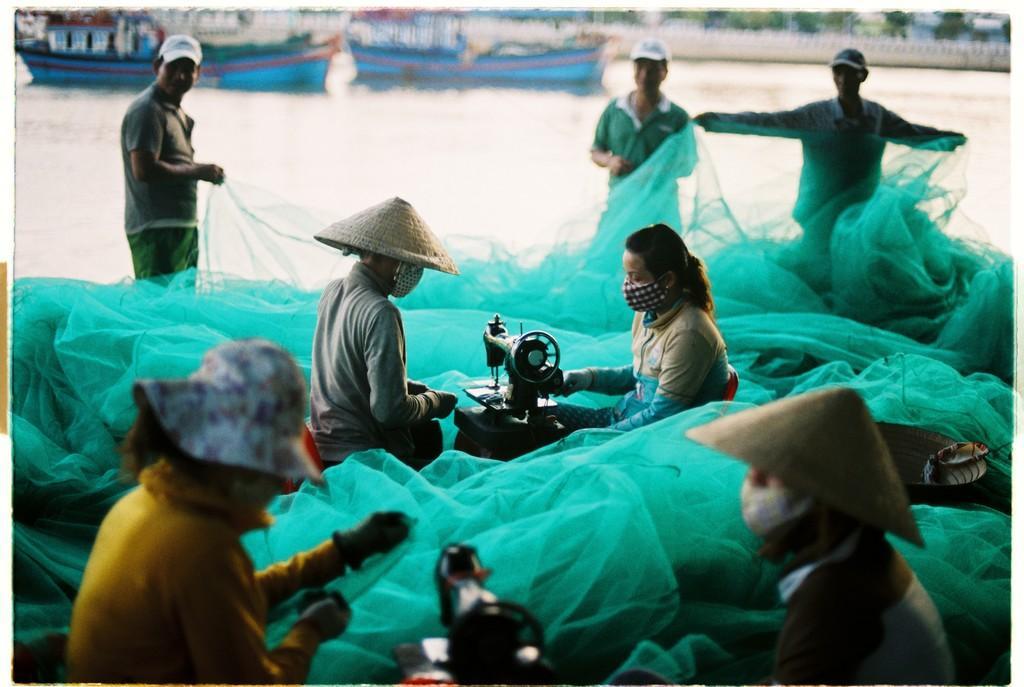Can you describe this image briefly? In this image, we can see people wearing caps and hats and some are wearing, masks and there are nets and we can see sewing machines. In the background, there is water and we can see trees, a fence and boats. 